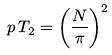Convert formula to latex. <formula><loc_0><loc_0><loc_500><loc_500>p \, T _ { 2 } = \left ( \frac { N } { \pi } \right ) ^ { 2 }</formula> 